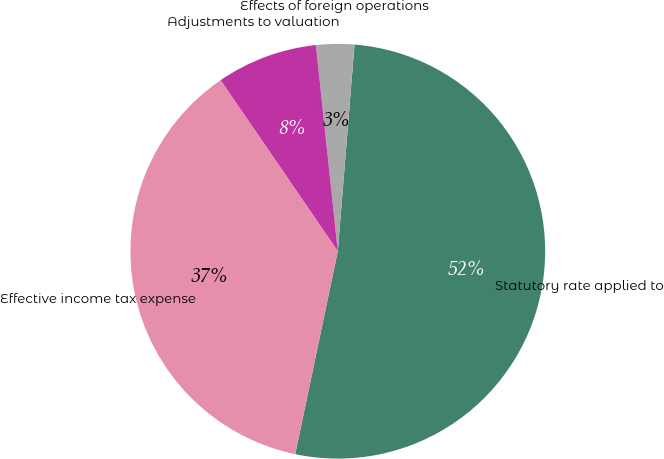Convert chart to OTSL. <chart><loc_0><loc_0><loc_500><loc_500><pie_chart><fcel>Statutory rate applied to<fcel>Effects of foreign operations<fcel>Adjustments to valuation<fcel>Effective income tax expense<nl><fcel>52.01%<fcel>2.97%<fcel>7.88%<fcel>37.15%<nl></chart> 